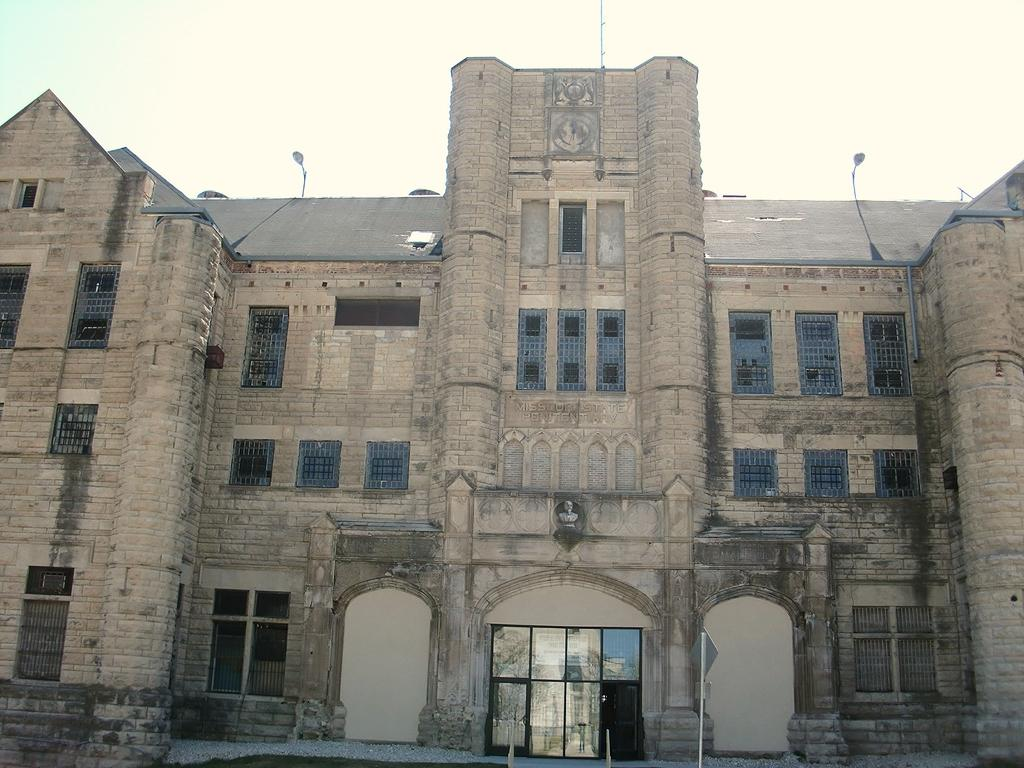What type of structure is present in the image? There is a building in the image. What features can be seen on the building? The building has windows and doors. What additional object is present in the image? There is a sculpture in the image. What is located at the top of the building? There are lights at the top of the building. What other object can be seen in the image? There is a pole in the image. What type of basin is located at the back of the building in the image? There is no basin present in the image, and the term "back" is not relevant to the image as it is a two-dimensional representation. 